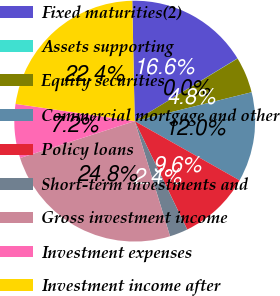<chart> <loc_0><loc_0><loc_500><loc_500><pie_chart><fcel>Fixed maturities(2)<fcel>Assets supporting<fcel>Equity securities<fcel>Commercial mortgage and other<fcel>Policy loans<fcel>Short-term investments and<fcel>Gross investment income<fcel>Investment expenses<fcel>Investment income after<nl><fcel>16.6%<fcel>0.03%<fcel>4.84%<fcel>12.04%<fcel>9.64%<fcel>2.44%<fcel>24.79%<fcel>7.24%<fcel>22.39%<nl></chart> 